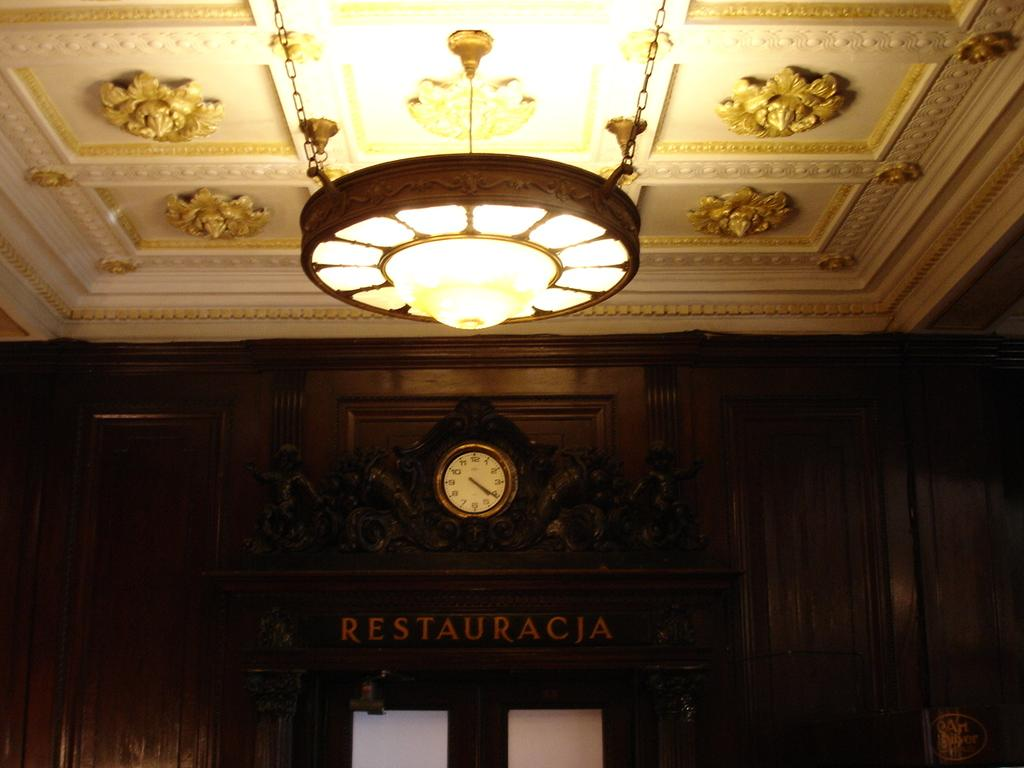<image>
Summarize the visual content of the image. A hanging light source is near the entrance to the building with the words restauracia on top of the doors. 